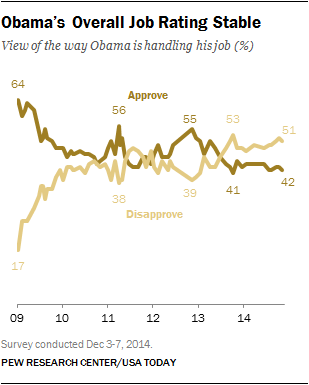Indicate a few pertinent items in this graphic. The lowest value in the graph is 17. The overall job approval rate of Barack Obama declined from 2009 to 2014, as analyzed in the given graph. 